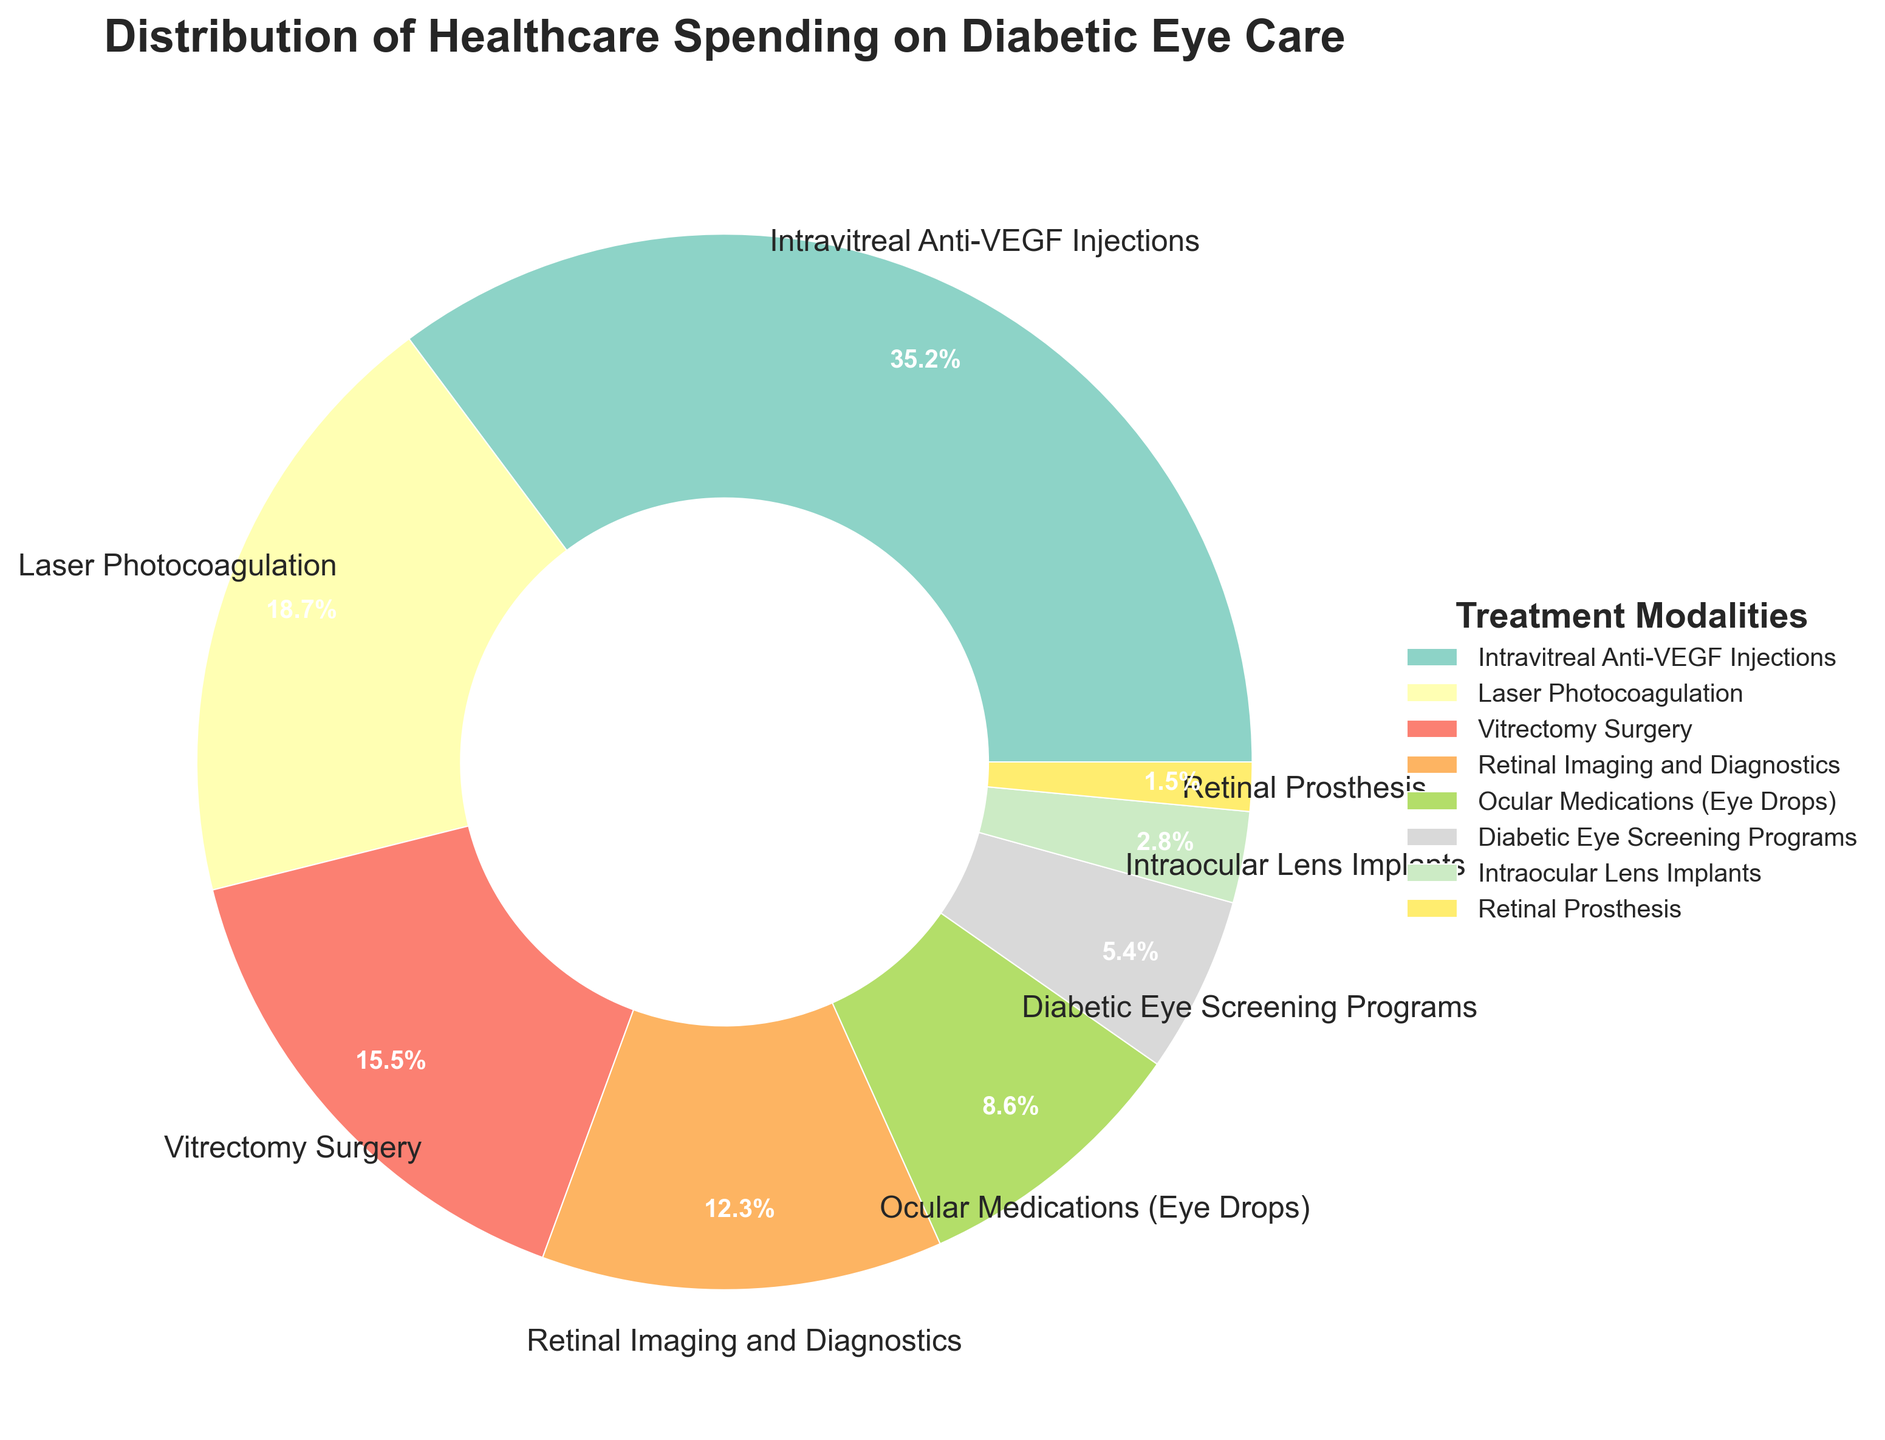What treatment modality has the highest healthcare spending percentage? The figure clearly shows that Intravitreal Anti-VEGF Injections occupy the largest portion of the pie chart. Therefore, it has the highest percentage of spending.
Answer: Intravitreal Anti-VEGF Injections What is the combined percentage of healthcare spending on Laser Photocoagulation and Vitrectomy Surgery? From the figure, Laser Photocoagulation accounts for 18.7% and Vitrectomy Surgery for 15.5%. Adding these together gives 18.7 + 15.5 = 34.2%.
Answer: 34.2% Which treatment modality has the least amount of healthcare spending, and what percentage is it? The smallest segment in the pie chart represents Retinal Prosthesis, which accounts for 1.5% of the spending.
Answer: Retinal Prosthesis, 1.5% What is the difference in the percentage of healthcare spending between Intravitreal Anti-VEGF Injections and Ocular Medications (Eye Drops)? Intravitreal Anti-VEGF Injections account for 35.2%, and Ocular Medications (Eye Drops) account for 8.6%. The difference is 35.2% - 8.6% = 26.6%.
Answer: 26.6% How much more is spent on Retinal Imaging and Diagnostics compared to Diabetic Eye Screening Programs? Retinal Imaging and Diagnostics account for 12.3%, whereas Diabetic Eye Screening Programs account for 5.4%. The difference is 12.3% - 5.4% = 6.9%.
Answer: 6.9% What percentage of healthcare spending is dedicated to treatment modalities other than Intravitreal Anti-VEGF Injections and Laser Photocoagulation? The combined percentage of Intravitreal Anti-VEGF Injections and Laser Photocoagulation is 35.2% + 18.7% = 53.9%. Thus, the remaining percentage is 100% - 53.9% = 46.1%.
Answer: 46.1% Which treatment modality has a greenish color in the pie chart and what is its percentage? The pie chart uses Set3 colormap. Given the random assignment of colors, the greenish color must be visually identified from the chart, and it corresponds to Laser Photocoagulation, which is 18.7%.
Answer: Laser Photocoagulation, 18.7% How do the percentages for Intraocular Lens Implants and Retinal Prosthesis compare? Intraocular Lens Implants account for 2.8%, and Retinal Prosthesis for 1.5%. Since 2.8% > 1.5%, Intraocular Lens Implants have a higher percentage of spending.
Answer: Intraocular Lens Implants > Retinal Prosthesis What is the average percentage of healthcare spending for all treatment modalities listed? To find the average, we sum all percentages: 35.2 + 18.7 + 15.5 + 12.3 + 8.6 + 5.4 + 2.8 + 1.5 = 100%. Hence, the average is 100% / 8 = 12.5%.
Answer: 12.5% What is the total percentage of healthcare spending allocated to the three treatment modalities with the lowest percentages? The treatment modalities with the lowest percentages are Intraocular Lens Implants (2.8%), Retinal Prosthesis (1.5%), and Diabetic Eye Screening Programs (5.4%). The total percentage is 2.8% + 1.5% + 5.4% = 9.7%.
Answer: 9.7% 